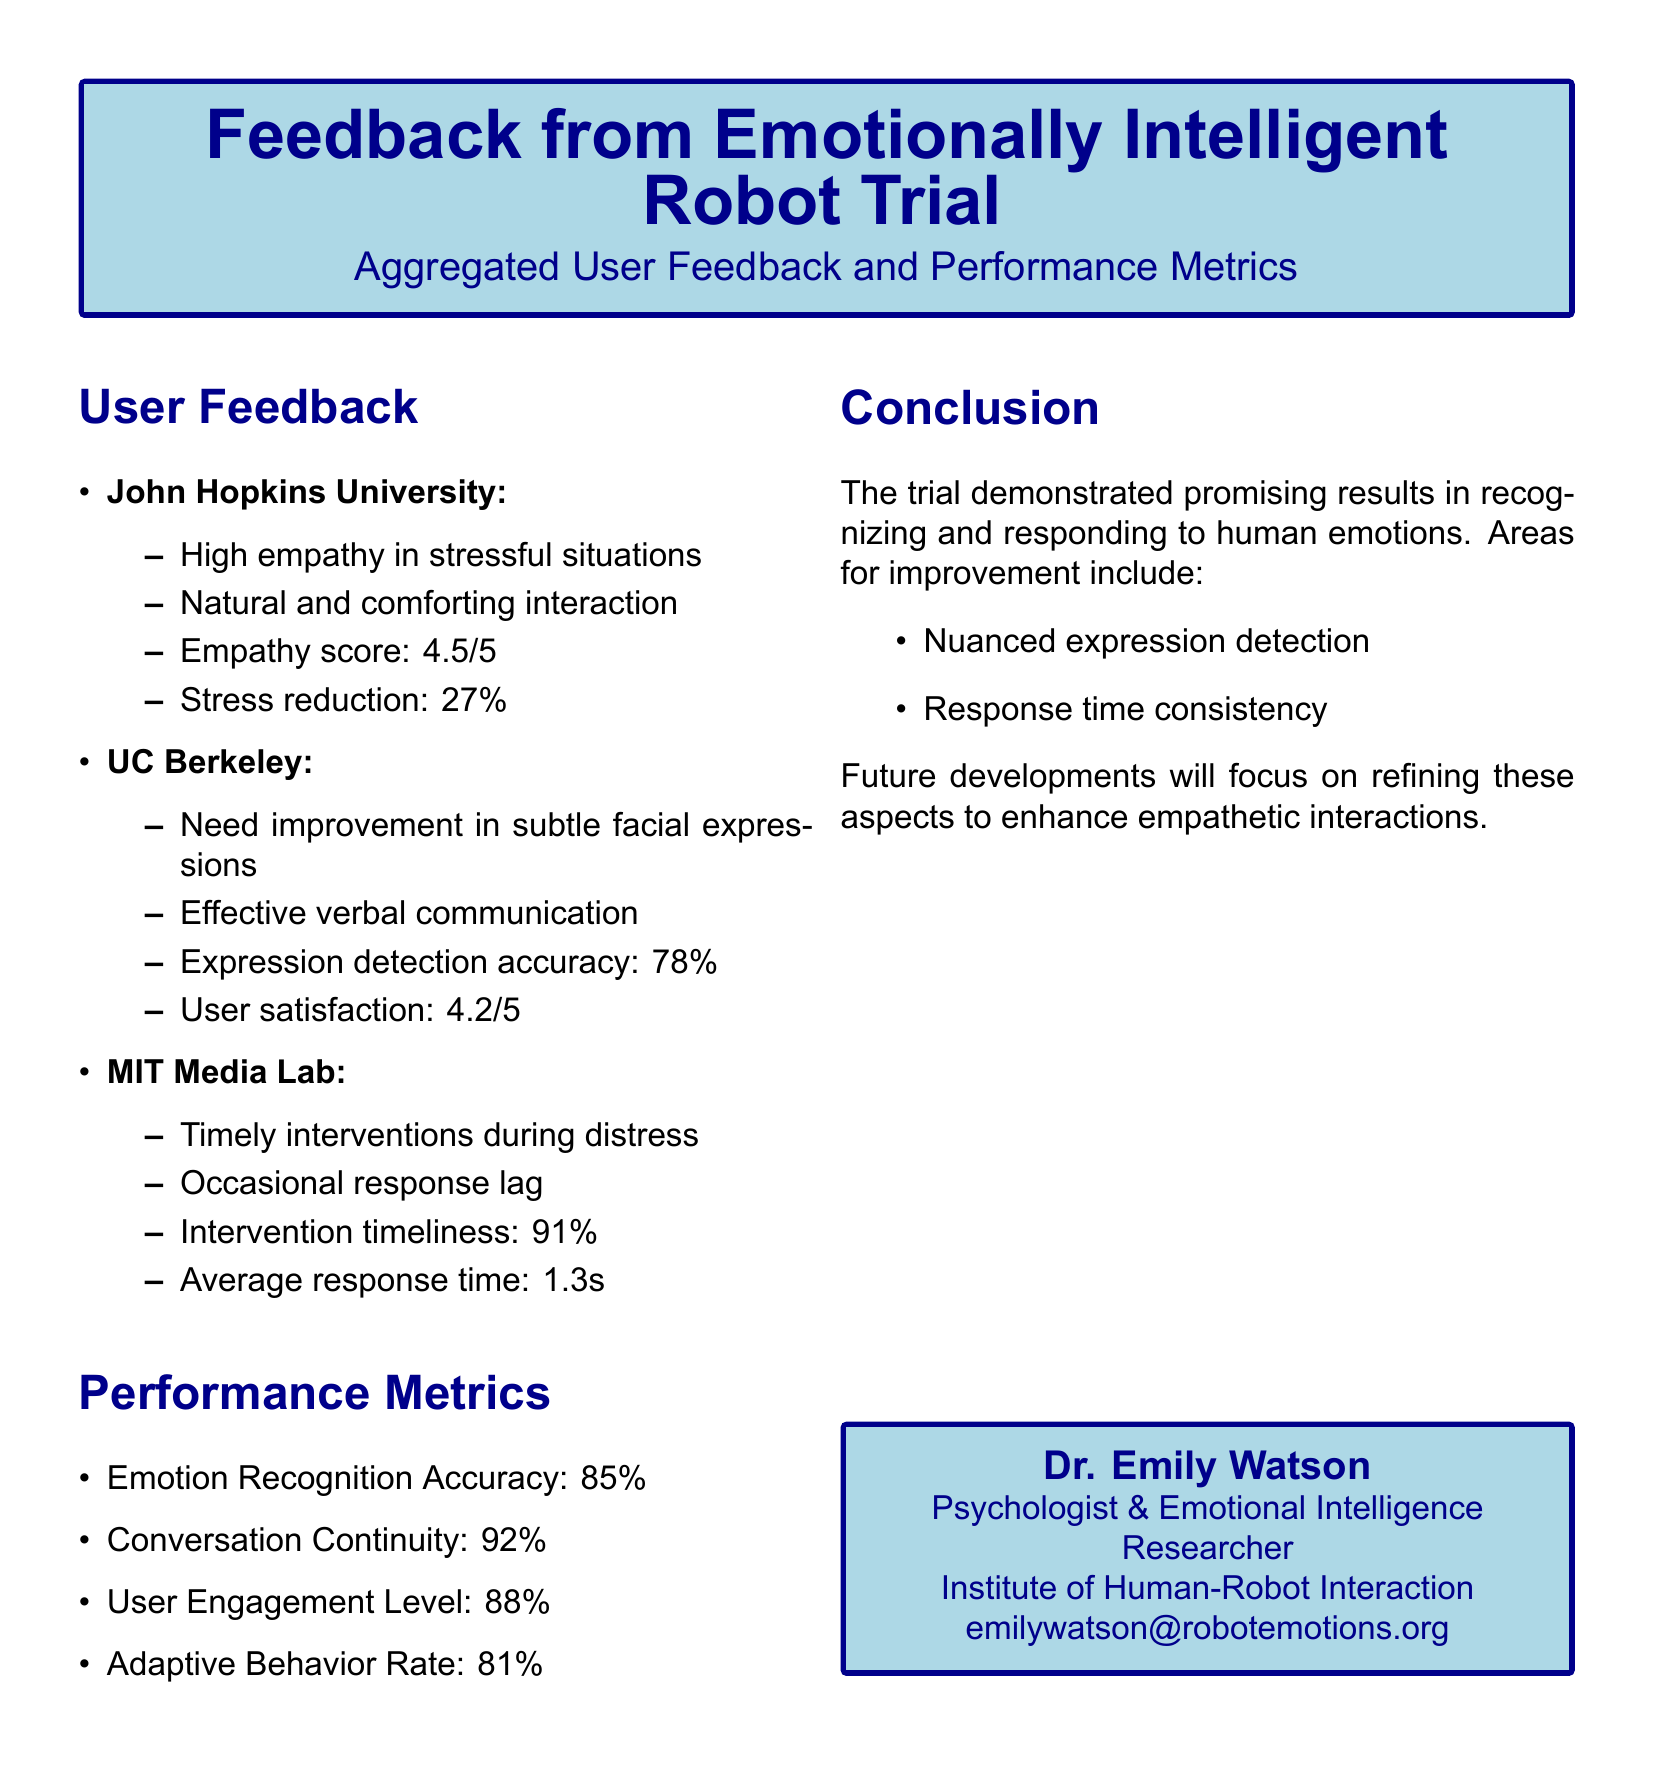what was the empathy score from John Hopkins University? The empathy score is a specific metric provided in the feedback section under John Hopkins University.
Answer: 4.5/5 what is the average response time reported by MIT Media Lab? Average response time is shown as a performance metric in the document, specifically from MIT Media Lab's feedback.
Answer: 1.3s what percentage of stress reduction was noted by John Hopkins University? Stress reduction is specified as a percentage in the feedback from John Hopkins University.
Answer: 27% what is the user satisfaction score given by UC Berkeley? User satisfaction is provided in the feedback section under UC Berkeley, detailing the users' experience with the robot.
Answer: 4.2/5 what is the emotion recognition accuracy reported in the performance metrics? Emotion recognition accuracy is a specific performance metric highlighted in the document.
Answer: 85% which institution noted a need for improvement in subtle facial expressions? This information is retrieved from the feedback section detailing each institution's feedback.
Answer: UC Berkeley what was the intervention timeliness percentage reported by MIT Media Lab? The intervention timeliness percentage is a key performance metric provided in the feedback from MIT Media Lab.
Answer: 91% what area for improvement is highlighted in the conclusion? The conclusion section lists specific areas for improvement based on user feedback.
Answer: Nuanced expression detection what is the user engagement level according to the performance metrics? User engagement level is one of the performance metrics provided in the document.
Answer: 88% 